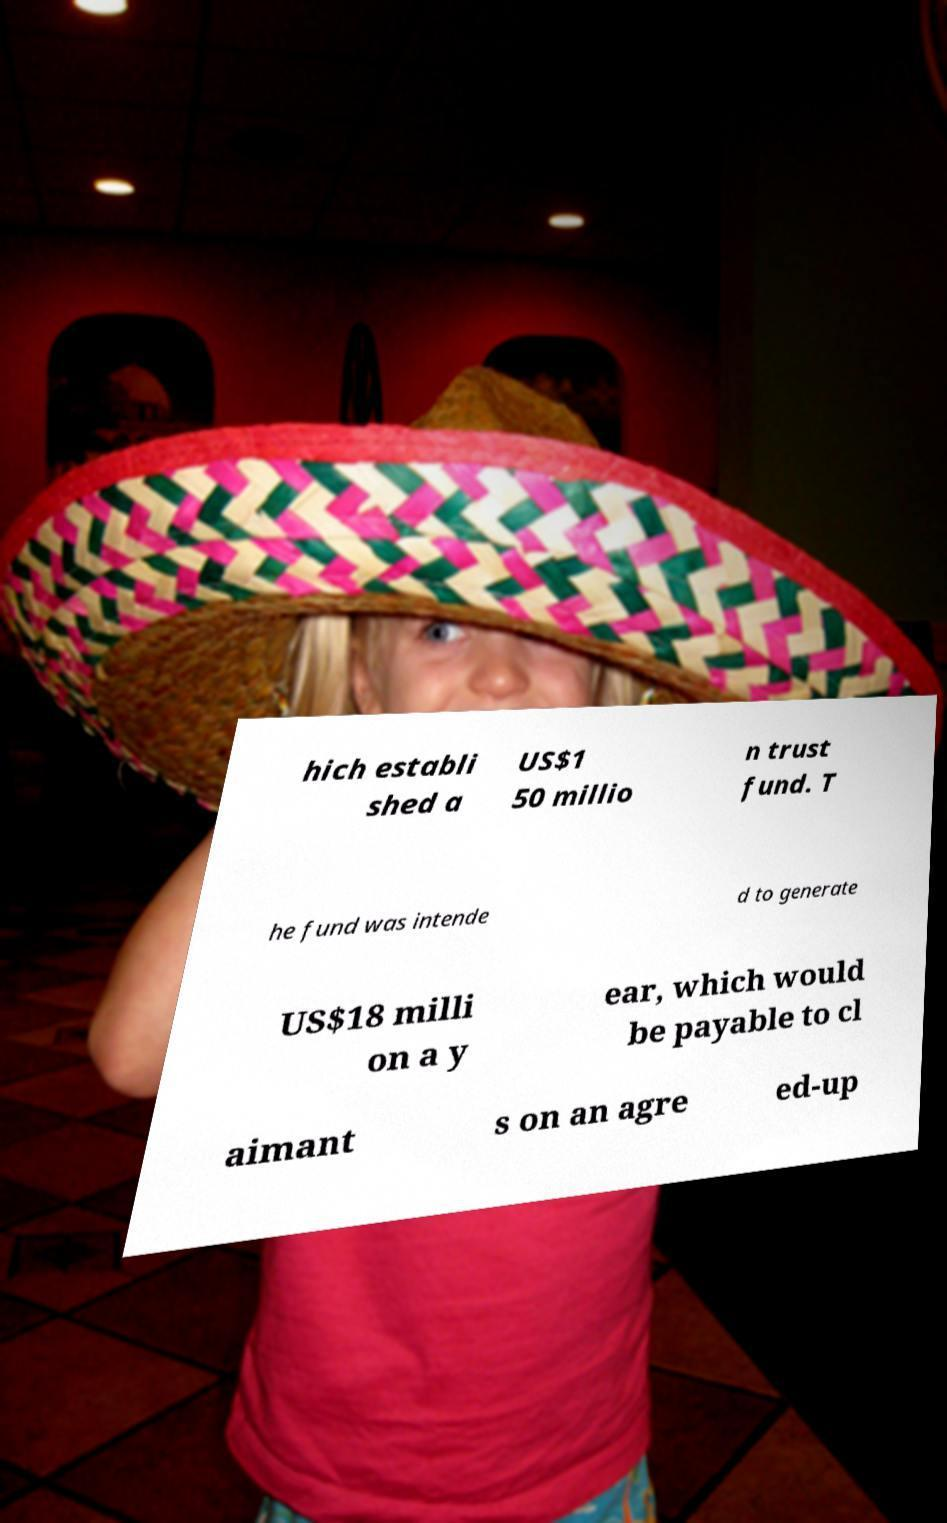There's text embedded in this image that I need extracted. Can you transcribe it verbatim? hich establi shed a US$1 50 millio n trust fund. T he fund was intende d to generate US$18 milli on a y ear, which would be payable to cl aimant s on an agre ed-up 